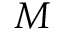Convert formula to latex. <formula><loc_0><loc_0><loc_500><loc_500>M</formula> 